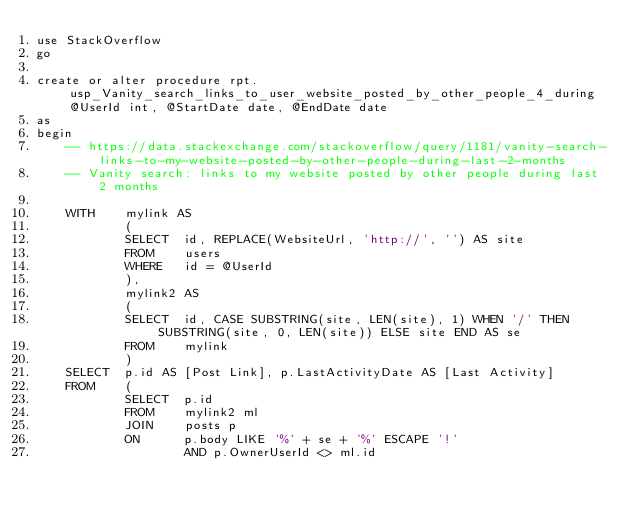Convert code to text. <code><loc_0><loc_0><loc_500><loc_500><_SQL_>use StackOverflow
go

create or alter procedure rpt.usp_Vanity_search_links_to_user_website_posted_by_other_people_4_during @UserId int, @StartDate date, @EndDate date
as
begin
	-- https://data.stackexchange.com/stackoverflow/query/1181/vanity-search-links-to-my-website-posted-by-other-people-during-last-2-months
	-- Vanity search: links to my website posted by other people during last 2 months

	WITH    mylink AS
			(
			SELECT  id, REPLACE(WebsiteUrl, 'http://', '') AS site
			FROM    users
			WHERE   id = @UserId
			),
			mylink2 AS
			(
			SELECT  id, CASE SUBSTRING(site, LEN(site), 1) WHEN '/' THEN SUBSTRING(site, 0, LEN(site)) ELSE site END AS se
			FROM    mylink
			)
	SELECT  p.id AS [Post Link], p.LastActivityDate AS [Last Activity]
	FROM    (
			SELECT  p.id
			FROM    mylink2 ml
			JOIN    posts p
			ON      p.body LIKE '%' + se + '%' ESCAPE '!'
					AND p.OwnerUserId <> ml.id</code> 